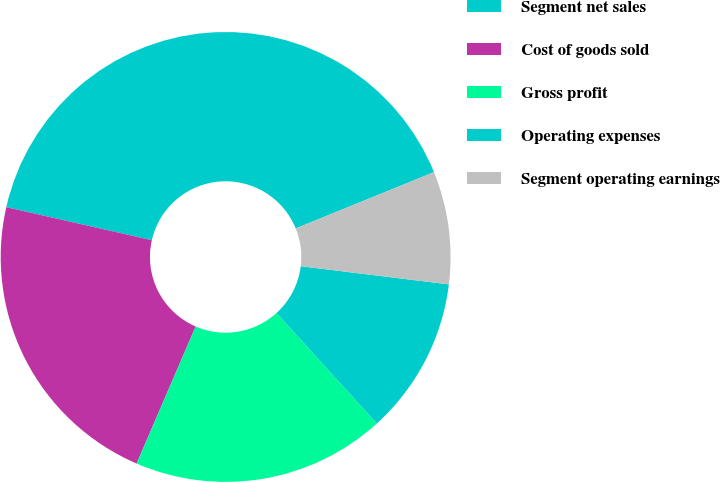<chart> <loc_0><loc_0><loc_500><loc_500><pie_chart><fcel>Segment net sales<fcel>Cost of goods sold<fcel>Gross profit<fcel>Operating expenses<fcel>Segment operating earnings<nl><fcel>40.29%<fcel>22.08%<fcel>18.21%<fcel>11.32%<fcel>8.1%<nl></chart> 